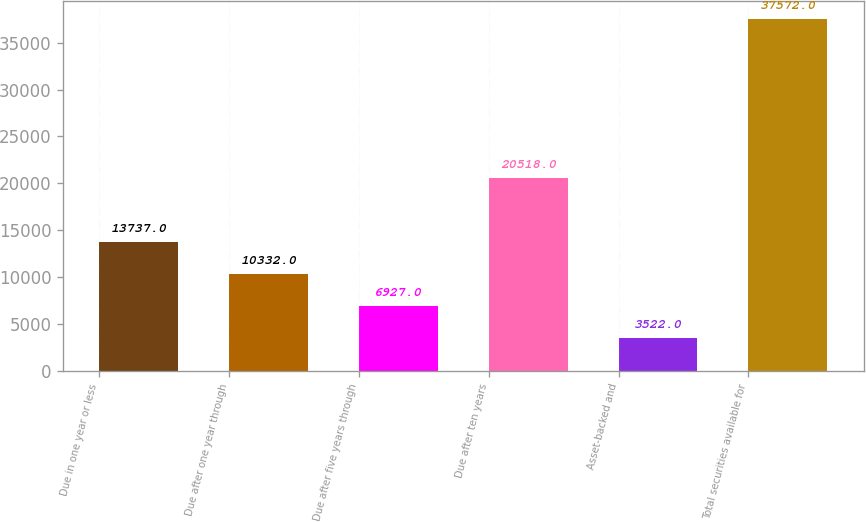Convert chart to OTSL. <chart><loc_0><loc_0><loc_500><loc_500><bar_chart><fcel>Due in one year or less<fcel>Due after one year through<fcel>Due after five years through<fcel>Due after ten years<fcel>Asset-backed and<fcel>Total securities available for<nl><fcel>13737<fcel>10332<fcel>6927<fcel>20518<fcel>3522<fcel>37572<nl></chart> 